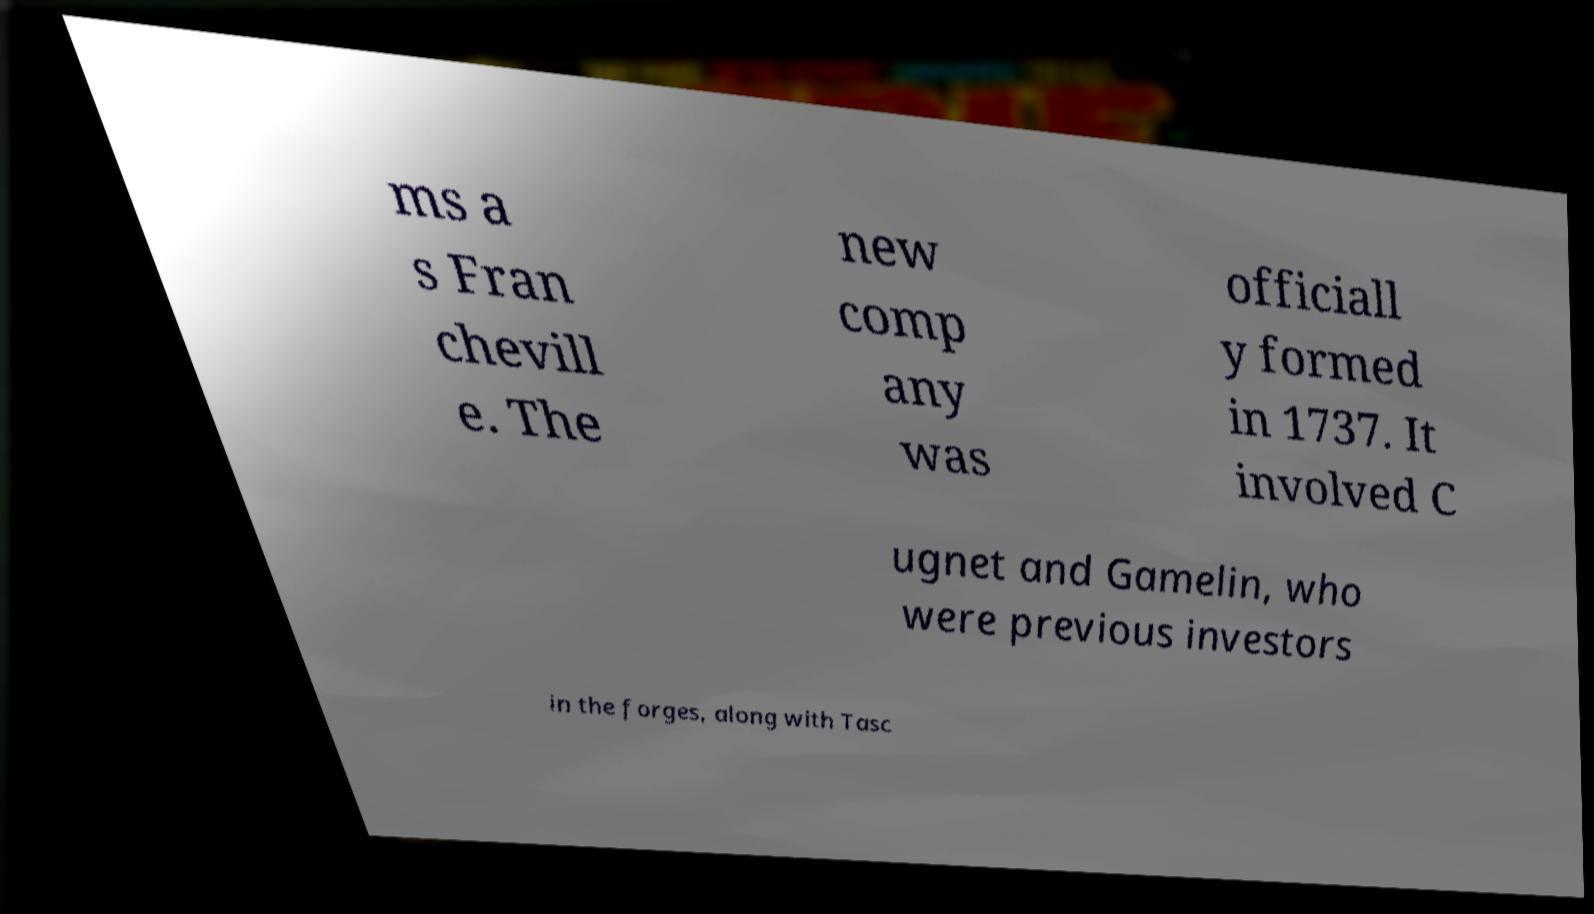Could you extract and type out the text from this image? ms a s Fran chevill e. The new comp any was officiall y formed in 1737. It involved C ugnet and Gamelin, who were previous investors in the forges, along with Tasc 